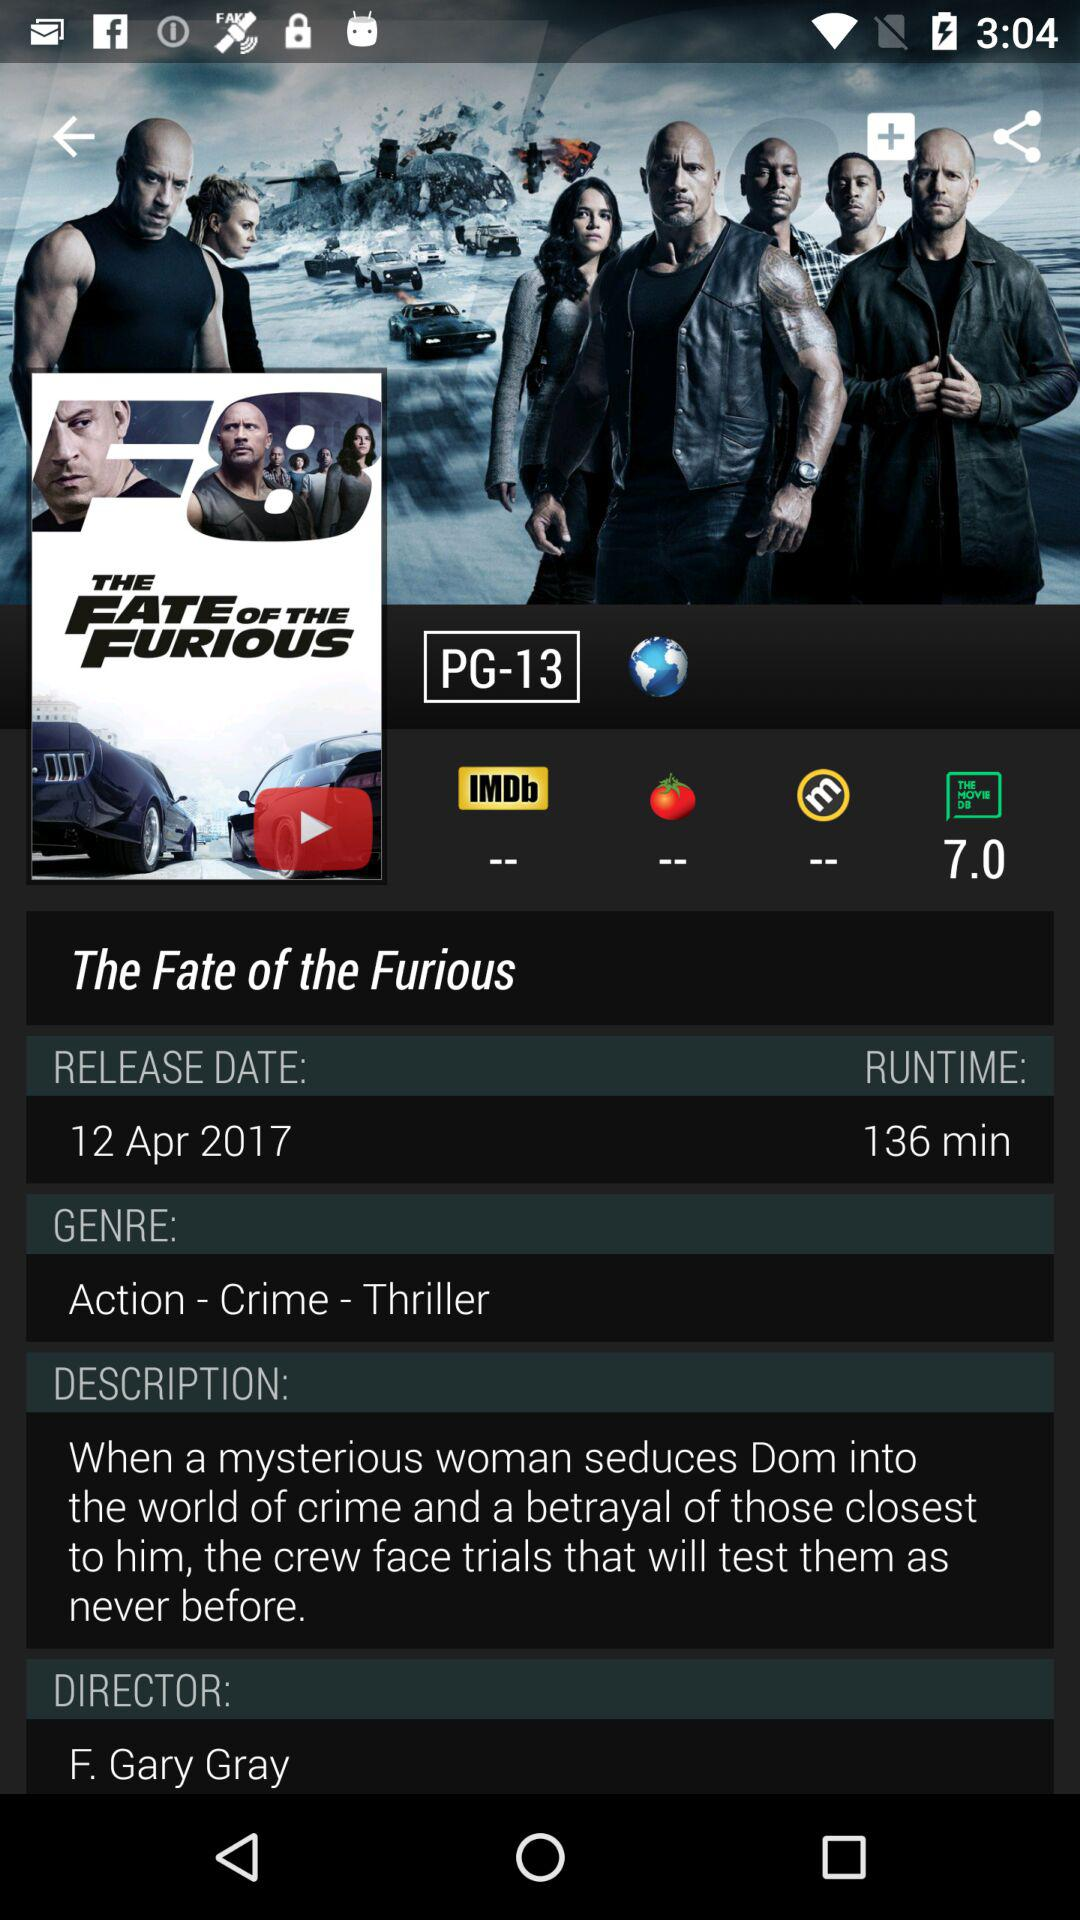What's the genre of the movie? The genres of the movie are action, crime and thriller. 